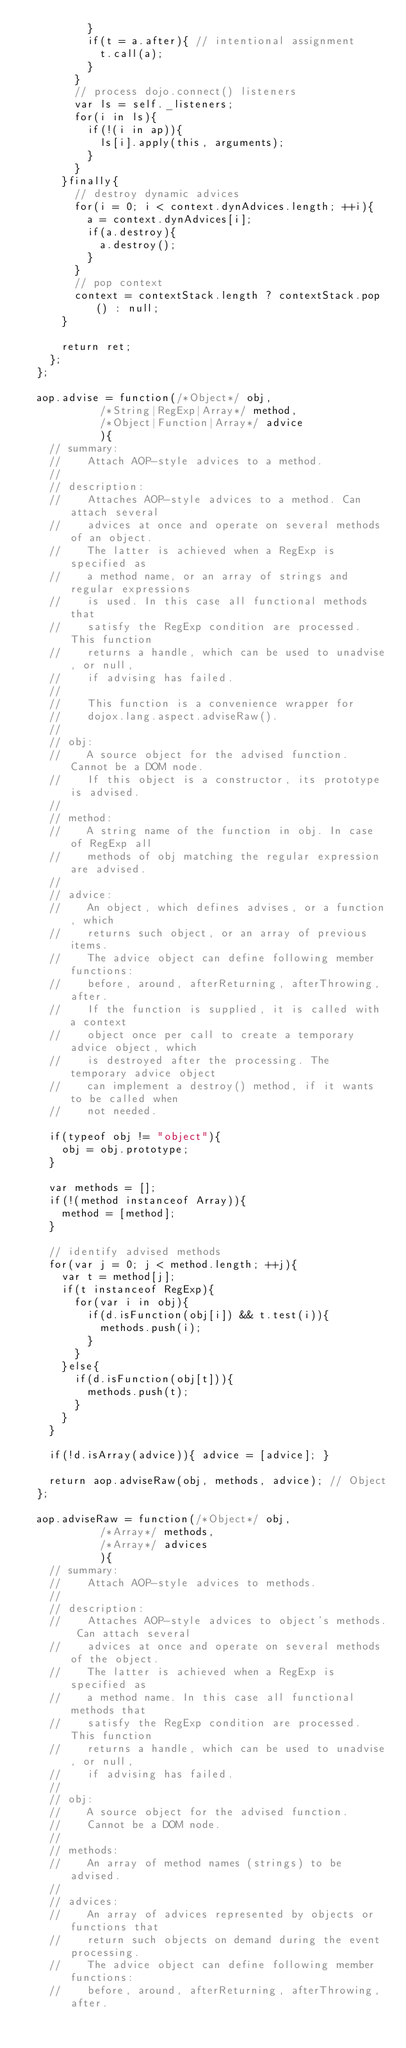Convert code to text. <code><loc_0><loc_0><loc_500><loc_500><_JavaScript_>					}
					if(t = a.after){ // intentional assignment
						t.call(a);
					}
				}
				// process dojo.connect() listeners
				var ls = self._listeners;
				for(i in ls){
					if(!(i in ap)){
						ls[i].apply(this, arguments);
					}
				}
			}finally{
				// destroy dynamic advices
				for(i = 0; i < context.dynAdvices.length; ++i){
					a = context.dynAdvices[i];
					if(a.destroy){
						a.destroy();
					}
				}
				// pop context
				context = contextStack.length ? contextStack.pop() : null;
			}
			
			return ret;
		};
	};

	aop.advise = function(/*Object*/ obj,
						/*String|RegExp|Array*/ method,
						/*Object|Function|Array*/ advice
						){
		// summary:
		//		Attach AOP-style advices to a method.
		//
		// description:
		//		Attaches AOP-style advices to a method. Can attach several
		//		advices at once and operate on several methods of an object.
		//		The latter is achieved when a RegExp is specified as
		//		a method name, or an array of strings and regular expressions
		//		is used. In this case all functional methods that
		//		satisfy the RegExp condition are processed. This function
		//		returns a handle, which can be used to unadvise, or null,
		//		if advising has failed.
		//
		//		This function is a convenience wrapper for
		//		dojox.lang.aspect.adviseRaw().
		//
		// obj:
		//		A source object for the advised function. Cannot be a DOM node.
		//		If this object is a constructor, its prototype is advised.
		//
		// method:
		//		A string name of the function in obj. In case of RegExp all
		//		methods of obj matching the regular expression are advised.
		//
		// advice:
		//		An object, which defines advises, or a function, which
		//		returns such object, or an array of previous items.
		//		The advice object can define following member functions:
		//		before, around, afterReturning, afterThrowing, after.
		//		If the function is supplied, it is called with a context
		//		object once per call to create a temporary advice object, which
		//		is destroyed after the processing. The temporary advice object
		//		can implement a destroy() method, if it wants to be called when
		//		not needed.
		
		if(typeof obj != "object"){
			obj = obj.prototype;
		}

		var methods = [];
		if(!(method instanceof Array)){
			method = [method];
		}
		
		// identify advised methods
		for(var j = 0; j < method.length; ++j){
			var t = method[j];
			if(t instanceof RegExp){
				for(var i in obj){
					if(d.isFunction(obj[i]) && t.test(i)){
						methods.push(i);
					}
				}
			}else{
				if(d.isFunction(obj[t])){
					methods.push(t);
				}
			}
		}

		if(!d.isArray(advice)){ advice = [advice]; }

		return aop.adviseRaw(obj, methods, advice);	// Object
	};
	
	aop.adviseRaw = function(/*Object*/ obj,
						/*Array*/ methods,
						/*Array*/ advices
						){
		// summary:
		//		Attach AOP-style advices to methods.
		//
		// description:
		//		Attaches AOP-style advices to object's methods. Can attach several
		//		advices at once and operate on several methods of the object.
		//		The latter is achieved when a RegExp is specified as
		//		a method name. In this case all functional methods that
		//		satisfy the RegExp condition are processed. This function
		//		returns a handle, which can be used to unadvise, or null,
		//		if advising has failed.
		//
		// obj:
		//		A source object for the advised function.
		//		Cannot be a DOM node.
		//
		// methods:
		//		An array of method names (strings) to be advised.
		//
		// advices:
		//		An array of advices represented by objects or functions that
		//		return such objects on demand during the event processing.
		//		The advice object can define following member functions:
		//		before, around, afterReturning, afterThrowing, after.</code> 